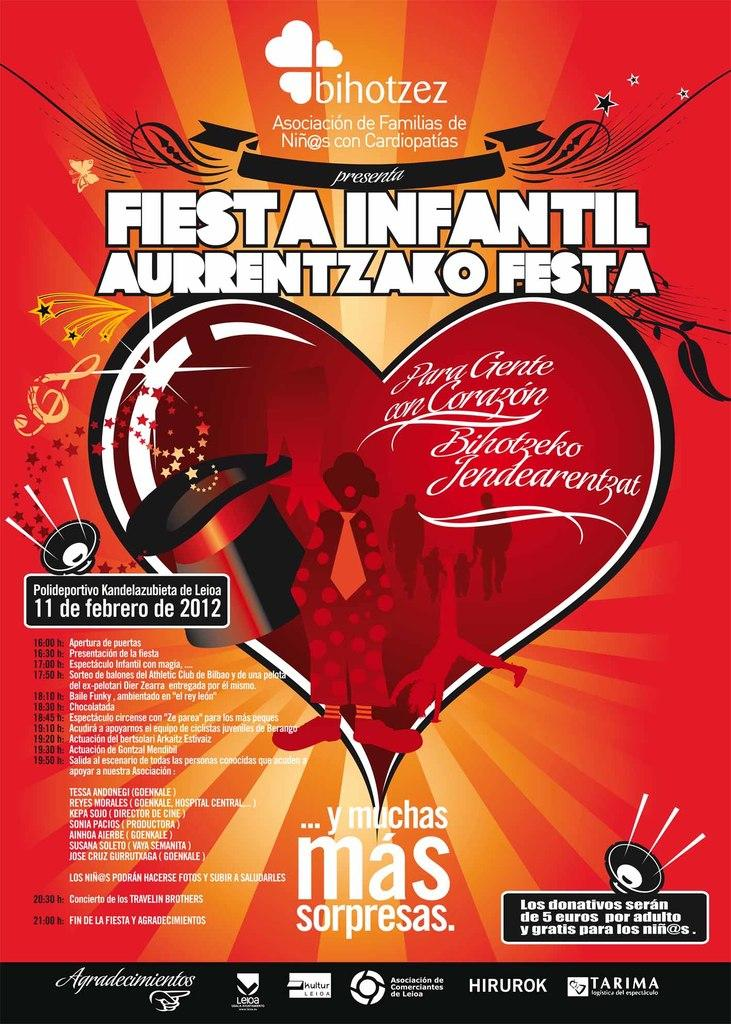Provide a one-sentence caption for the provided image. Poster for Fiesta Infantil Aurrentizako Festa in 2012. 